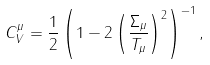Convert formula to latex. <formula><loc_0><loc_0><loc_500><loc_500>C _ { V } ^ { \mu } = \frac { 1 } { 2 } \left ( 1 - 2 \left ( \frac { \Sigma _ { \mu } } { T _ { \mu } } \right ) ^ { 2 } \right ) ^ { - 1 } ,</formula> 